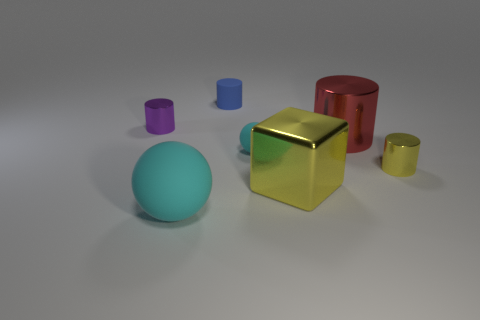There is a thing that is the same color as the large shiny cube; what is its shape?
Ensure brevity in your answer.  Cylinder. The yellow thing that is to the left of the big shiny object behind the small metal cylinder in front of the purple metal object is made of what material?
Offer a terse response. Metal. Does the small matte object that is behind the purple object have the same shape as the large yellow object?
Provide a succinct answer. No. What is the material of the cyan sphere in front of the small matte sphere?
Make the answer very short. Rubber. What number of matte objects are either balls or large purple objects?
Provide a succinct answer. 2. Is there a rubber object that has the same size as the yellow shiny cylinder?
Offer a terse response. Yes. Are there more blue matte cylinders that are in front of the red metallic thing than tiny gray matte blocks?
Offer a terse response. No. What number of big objects are either purple blocks or blue objects?
Offer a very short reply. 0. What number of rubber things are the same shape as the tiny yellow metallic object?
Provide a short and direct response. 1. There is a cyan ball in front of the small metal object that is in front of the large red metallic thing; what is its material?
Offer a very short reply. Rubber. 